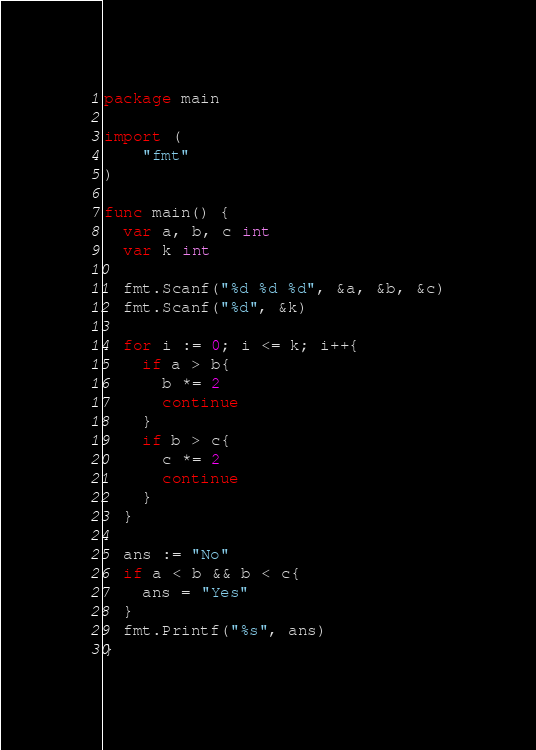<code> <loc_0><loc_0><loc_500><loc_500><_Go_>package main
 
import (
	"fmt"
)
 
func main() {
  var a, b, c int
  var k int
  
  fmt.Scanf("%d %d %d", &a, &b, &c)
  fmt.Scanf("%d", &k)
  
  for i := 0; i <= k; i++{
    if a > b{
      b *= 2
      continue
    }
    if b > c{
      c *= 2
      continue
    }
  }
  
  ans := "No"
  if a < b && b < c{
    ans = "Yes"
  }
  fmt.Printf("%s", ans)
}</code> 